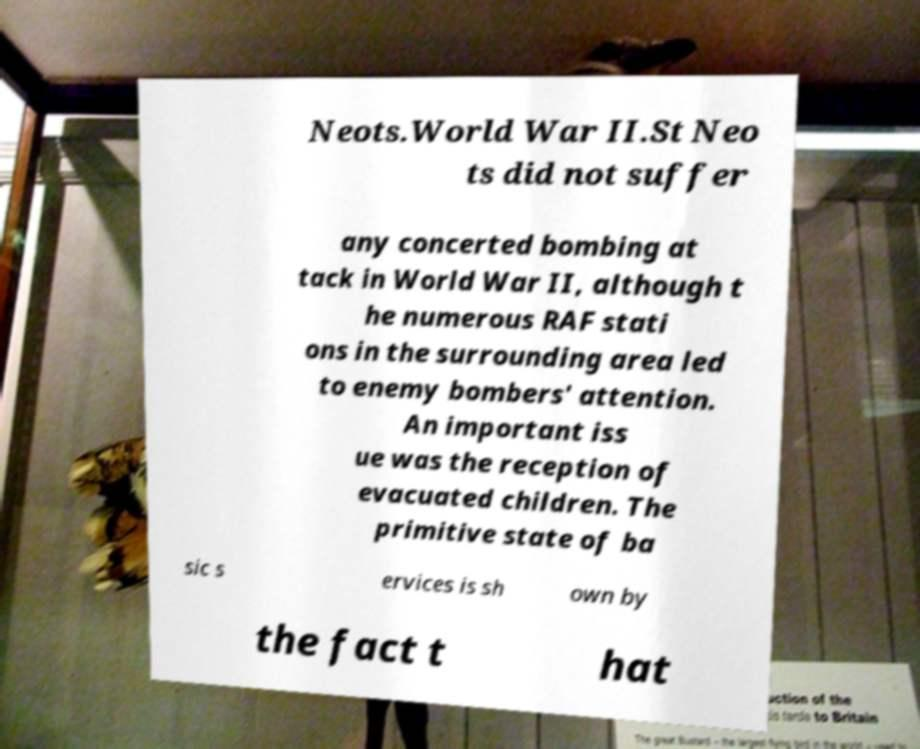Can you accurately transcribe the text from the provided image for me? Neots.World War II.St Neo ts did not suffer any concerted bombing at tack in World War II, although t he numerous RAF stati ons in the surrounding area led to enemy bombers' attention. An important iss ue was the reception of evacuated children. The primitive state of ba sic s ervices is sh own by the fact t hat 